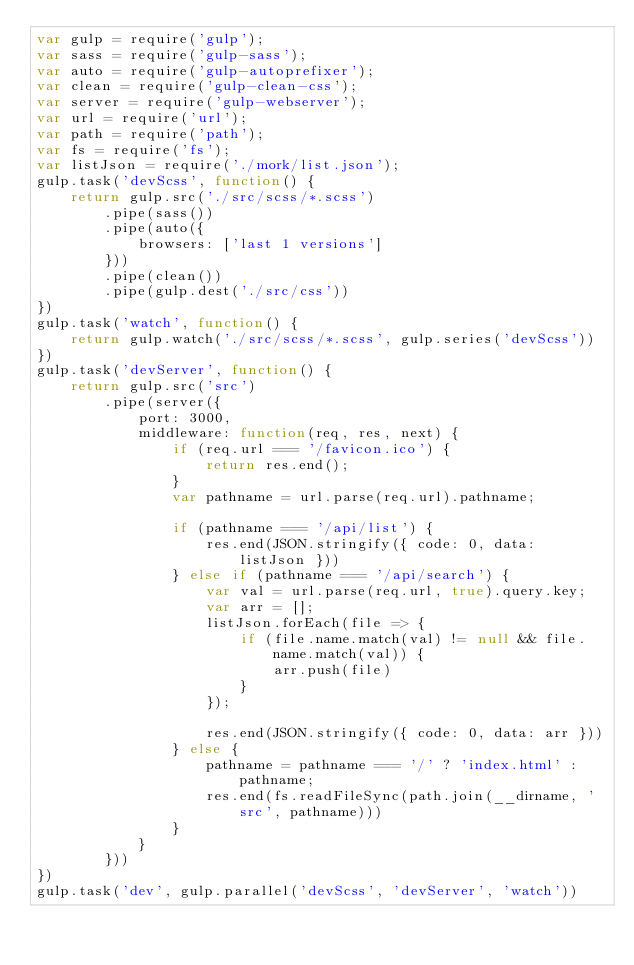<code> <loc_0><loc_0><loc_500><loc_500><_JavaScript_>var gulp = require('gulp');
var sass = require('gulp-sass');
var auto = require('gulp-autoprefixer');
var clean = require('gulp-clean-css');
var server = require('gulp-webserver');
var url = require('url');
var path = require('path');
var fs = require('fs');
var listJson = require('./mork/list.json');
gulp.task('devScss', function() {
    return gulp.src('./src/scss/*.scss')
        .pipe(sass())
        .pipe(auto({
            browsers: ['last 1 versions']
        }))
        .pipe(clean())
        .pipe(gulp.dest('./src/css'))
})
gulp.task('watch', function() {
    return gulp.watch('./src/scss/*.scss', gulp.series('devScss'))
})
gulp.task('devServer', function() {
    return gulp.src('src')
        .pipe(server({
            port: 3000,
            middleware: function(req, res, next) {
                if (req.url === '/favicon.ico') {
                    return res.end();
                }
                var pathname = url.parse(req.url).pathname;

                if (pathname === '/api/list') {
                    res.end(JSON.stringify({ code: 0, data: listJson }))
                } else if (pathname === '/api/search') {
                    var val = url.parse(req.url, true).query.key;
                    var arr = [];
                    listJson.forEach(file => {
                        if (file.name.match(val) != null && file.name.match(val)) {
                            arr.push(file)
                        }
                    });

                    res.end(JSON.stringify({ code: 0, data: arr }))
                } else {
                    pathname = pathname === '/' ? 'index.html' : pathname;
                    res.end(fs.readFileSync(path.join(__dirname, 'src', pathname)))
                }
            }
        }))
})
gulp.task('dev', gulp.parallel('devScss', 'devServer', 'watch'))</code> 